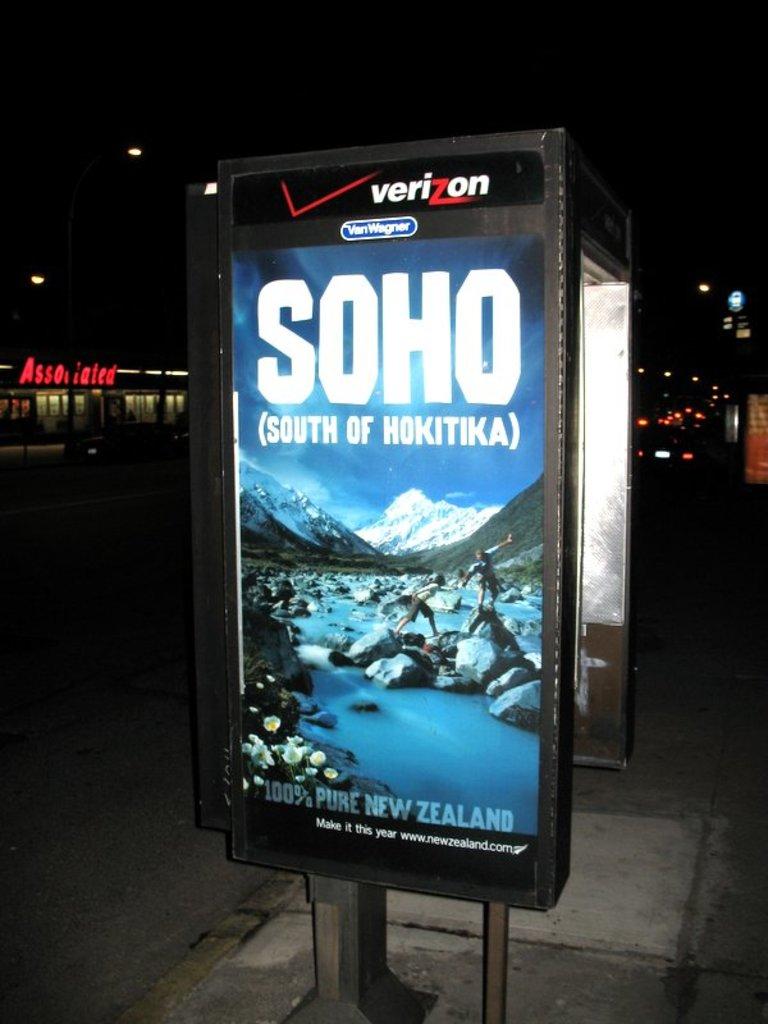What phone brand is this?
Ensure brevity in your answer.  Verizon. 